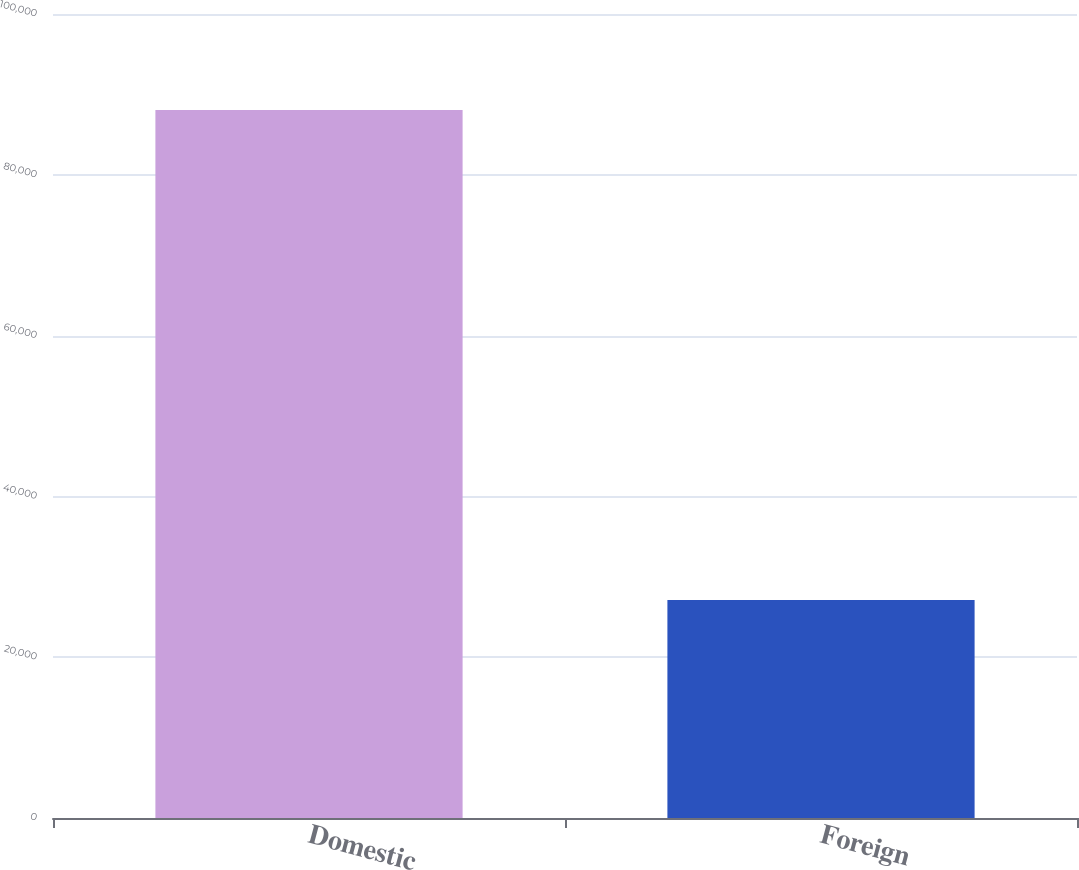Convert chart to OTSL. <chart><loc_0><loc_0><loc_500><loc_500><bar_chart><fcel>Domestic<fcel>Foreign<nl><fcel>88065<fcel>27103<nl></chart> 